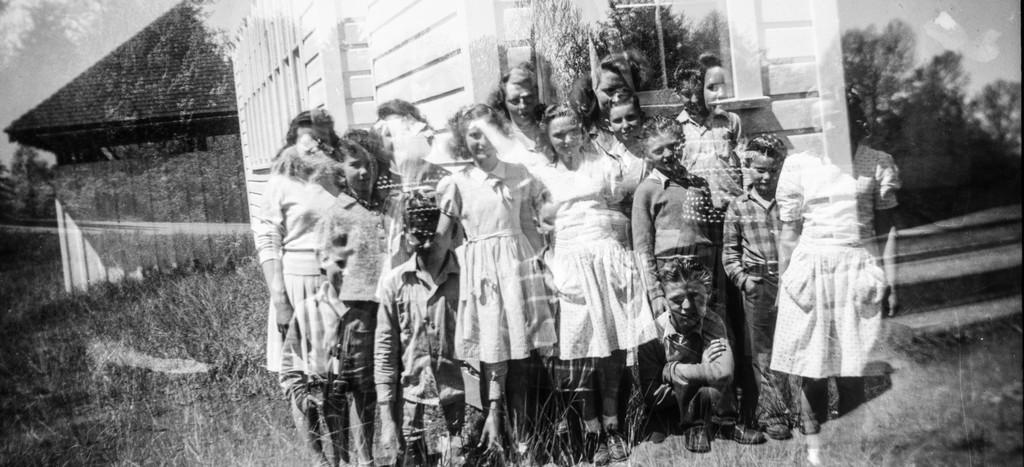What is happening in the image? There are people standing in the image. What can be seen in the distance behind the people? There are buildings visible in the background of the image. What type of vegetation is present in the image? Trees are present in the image. What is the ground made of in the image? Grass is visible on the ground in the image. What color are the eyes of the goat in the image? There is no goat present in the image, so we cannot determine the color of its eyes. What tool is being used to dig in the image? There is no tool being used to dig in the image. 